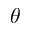Convert formula to latex. <formula><loc_0><loc_0><loc_500><loc_500>\theta</formula> 